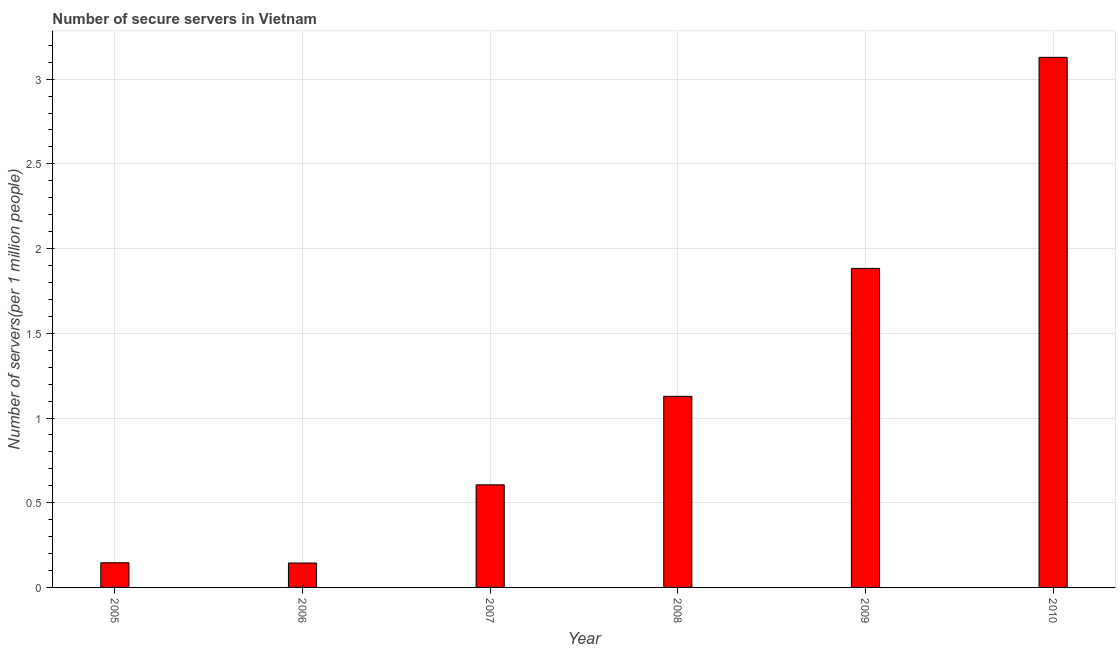Does the graph contain any zero values?
Give a very brief answer. No. Does the graph contain grids?
Keep it short and to the point. Yes. What is the title of the graph?
Make the answer very short. Number of secure servers in Vietnam. What is the label or title of the X-axis?
Your response must be concise. Year. What is the label or title of the Y-axis?
Your answer should be very brief. Number of servers(per 1 million people). What is the number of secure internet servers in 2009?
Keep it short and to the point. 1.88. Across all years, what is the maximum number of secure internet servers?
Make the answer very short. 3.13. Across all years, what is the minimum number of secure internet servers?
Your answer should be very brief. 0.14. In which year was the number of secure internet servers minimum?
Make the answer very short. 2006. What is the sum of the number of secure internet servers?
Your response must be concise. 7.04. What is the difference between the number of secure internet servers in 2009 and 2010?
Your answer should be very brief. -1.25. What is the average number of secure internet servers per year?
Your response must be concise. 1.17. What is the median number of secure internet servers?
Your response must be concise. 0.87. What is the ratio of the number of secure internet servers in 2005 to that in 2007?
Give a very brief answer. 0.24. Is the number of secure internet servers in 2005 less than that in 2009?
Give a very brief answer. Yes. What is the difference between the highest and the second highest number of secure internet servers?
Make the answer very short. 1.25. What is the difference between the highest and the lowest number of secure internet servers?
Provide a succinct answer. 2.98. In how many years, is the number of secure internet servers greater than the average number of secure internet servers taken over all years?
Your response must be concise. 2. How many bars are there?
Make the answer very short. 6. Are the values on the major ticks of Y-axis written in scientific E-notation?
Make the answer very short. No. What is the Number of servers(per 1 million people) of 2005?
Your response must be concise. 0.15. What is the Number of servers(per 1 million people) in 2006?
Make the answer very short. 0.14. What is the Number of servers(per 1 million people) in 2007?
Your answer should be very brief. 0.61. What is the Number of servers(per 1 million people) of 2008?
Offer a terse response. 1.13. What is the Number of servers(per 1 million people) in 2009?
Make the answer very short. 1.88. What is the Number of servers(per 1 million people) of 2010?
Provide a short and direct response. 3.13. What is the difference between the Number of servers(per 1 million people) in 2005 and 2006?
Give a very brief answer. 0. What is the difference between the Number of servers(per 1 million people) in 2005 and 2007?
Offer a terse response. -0.46. What is the difference between the Number of servers(per 1 million people) in 2005 and 2008?
Your response must be concise. -0.98. What is the difference between the Number of servers(per 1 million people) in 2005 and 2009?
Keep it short and to the point. -1.74. What is the difference between the Number of servers(per 1 million people) in 2005 and 2010?
Provide a short and direct response. -2.98. What is the difference between the Number of servers(per 1 million people) in 2006 and 2007?
Provide a short and direct response. -0.46. What is the difference between the Number of servers(per 1 million people) in 2006 and 2008?
Keep it short and to the point. -0.98. What is the difference between the Number of servers(per 1 million people) in 2006 and 2009?
Give a very brief answer. -1.74. What is the difference between the Number of servers(per 1 million people) in 2006 and 2010?
Make the answer very short. -2.98. What is the difference between the Number of servers(per 1 million people) in 2007 and 2008?
Your answer should be very brief. -0.52. What is the difference between the Number of servers(per 1 million people) in 2007 and 2009?
Provide a short and direct response. -1.28. What is the difference between the Number of servers(per 1 million people) in 2007 and 2010?
Provide a short and direct response. -2.52. What is the difference between the Number of servers(per 1 million people) in 2008 and 2009?
Ensure brevity in your answer.  -0.76. What is the difference between the Number of servers(per 1 million people) in 2008 and 2010?
Provide a succinct answer. -2. What is the difference between the Number of servers(per 1 million people) in 2009 and 2010?
Your answer should be compact. -1.25. What is the ratio of the Number of servers(per 1 million people) in 2005 to that in 2006?
Provide a succinct answer. 1.01. What is the ratio of the Number of servers(per 1 million people) in 2005 to that in 2007?
Provide a short and direct response. 0.24. What is the ratio of the Number of servers(per 1 million people) in 2005 to that in 2008?
Keep it short and to the point. 0.13. What is the ratio of the Number of servers(per 1 million people) in 2005 to that in 2009?
Your answer should be very brief. 0.08. What is the ratio of the Number of servers(per 1 million people) in 2005 to that in 2010?
Offer a very short reply. 0.05. What is the ratio of the Number of servers(per 1 million people) in 2006 to that in 2007?
Your answer should be compact. 0.24. What is the ratio of the Number of servers(per 1 million people) in 2006 to that in 2008?
Offer a terse response. 0.13. What is the ratio of the Number of servers(per 1 million people) in 2006 to that in 2009?
Your answer should be very brief. 0.08. What is the ratio of the Number of servers(per 1 million people) in 2006 to that in 2010?
Provide a short and direct response. 0.05. What is the ratio of the Number of servers(per 1 million people) in 2007 to that in 2008?
Your response must be concise. 0.54. What is the ratio of the Number of servers(per 1 million people) in 2007 to that in 2009?
Your answer should be very brief. 0.32. What is the ratio of the Number of servers(per 1 million people) in 2007 to that in 2010?
Provide a succinct answer. 0.19. What is the ratio of the Number of servers(per 1 million people) in 2008 to that in 2009?
Your answer should be compact. 0.6. What is the ratio of the Number of servers(per 1 million people) in 2008 to that in 2010?
Provide a short and direct response. 0.36. What is the ratio of the Number of servers(per 1 million people) in 2009 to that in 2010?
Your answer should be very brief. 0.6. 